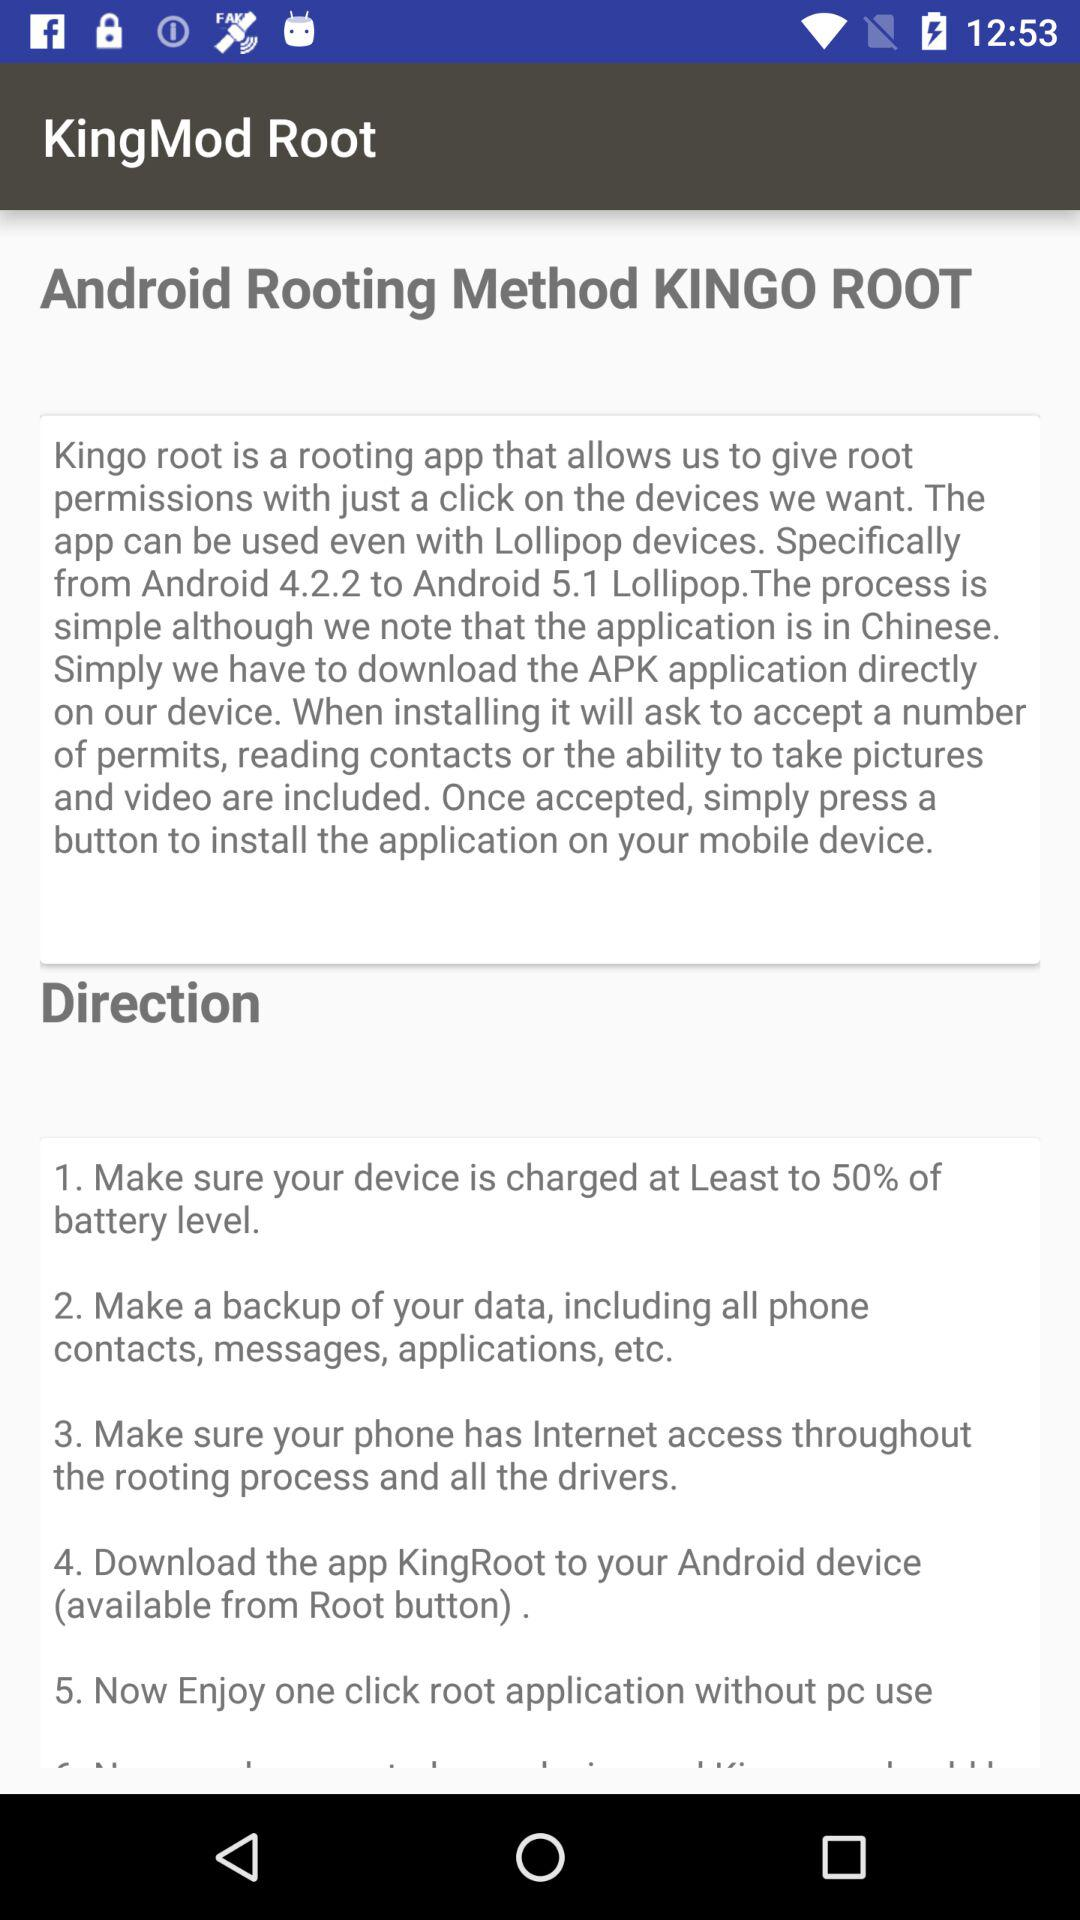What are the steps to follow to get root access? The steps to follow are "Simply we have to download the APK application directly on our device. When installing it will ask to accept a number of permits, reading contacts or the ability to take pictures and video are included. Once accepted, simply press a button to install the application on your mobile device". 